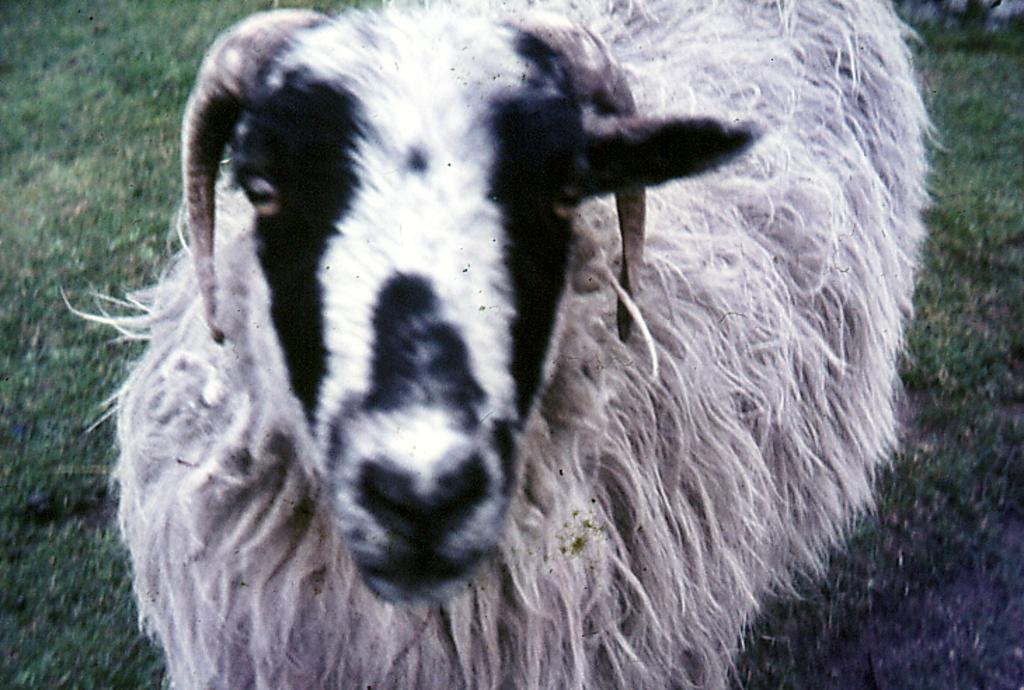What type of animal is standing in the image? The specific type of animal cannot be determined from the provided facts. What is at the bottom of the image? There is grass at the bottom of the image. Can you describe the other animal in the image? There appears to be another animal at the top right of the image, but its specific type cannot be determined from the provided facts. What type of card is being held by the farmer in the image? There is no farmer or card present in the image. What color is the flag flying above the animal in the image? There is no flag present in the image. 